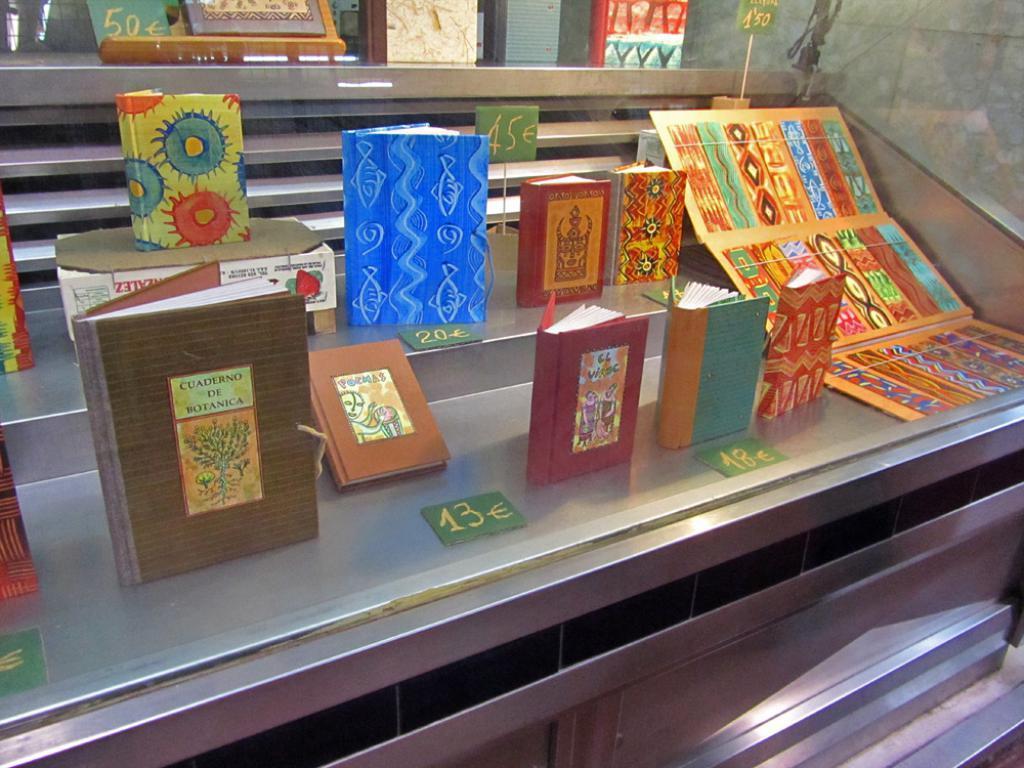Please provide a concise description of this image. In this image there are books on the stand and there is a cardboard with some design on it and there are numbers written on the paper. 